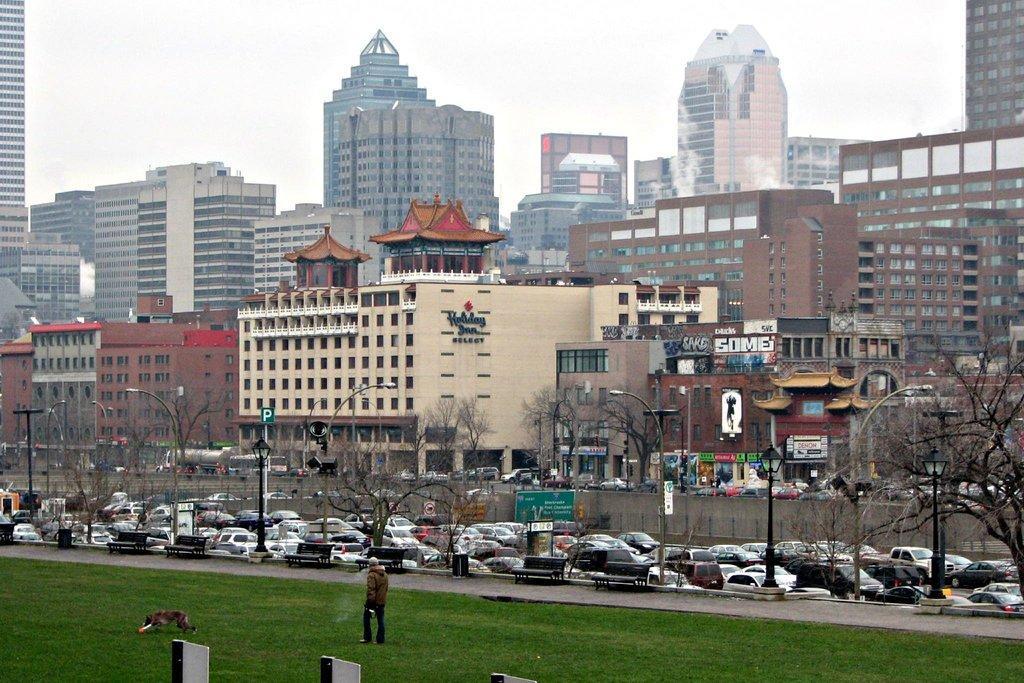How would you summarize this image in a sentence or two? In this image there are a group of buildings and houses, poles, lights, boards. At the bottom there is grass and one person is walking and there is one dog, in the center there are some vehicles. 